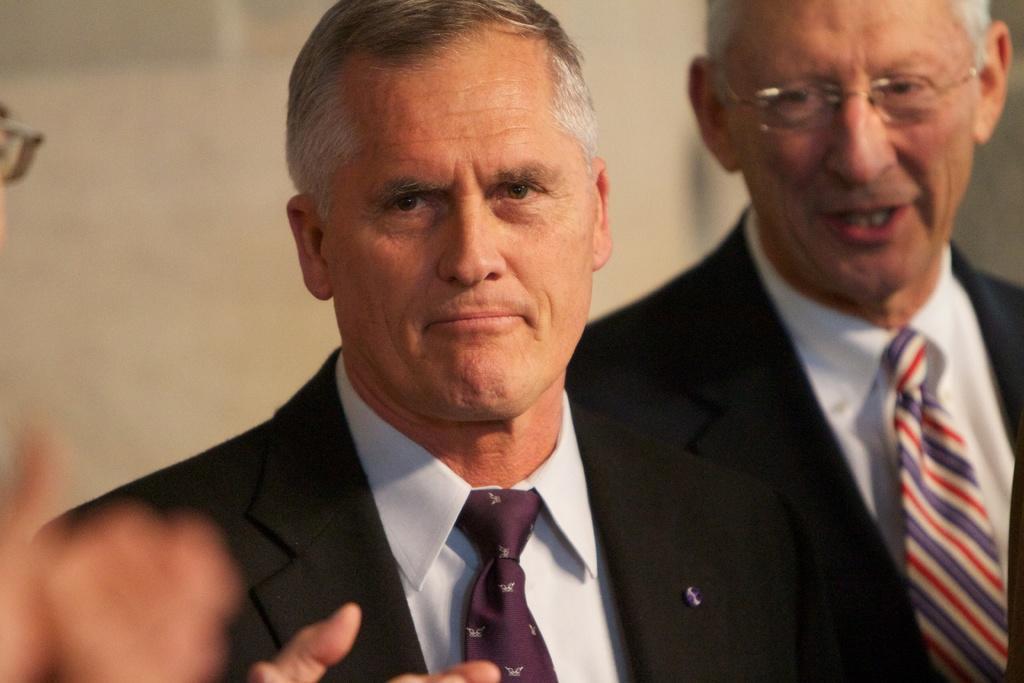How would you summarize this image in a sentence or two? There is a man in the center of the image and there are other people on both the sides. 